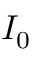Convert formula to latex. <formula><loc_0><loc_0><loc_500><loc_500>I _ { 0 }</formula> 